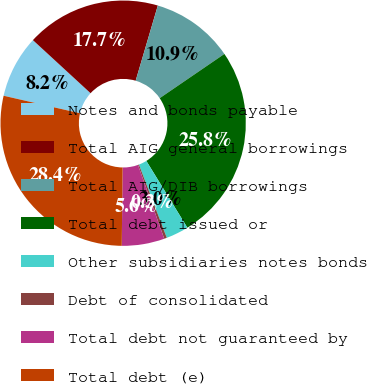Convert chart. <chart><loc_0><loc_0><loc_500><loc_500><pie_chart><fcel>Notes and bonds payable<fcel>Total AIG general borrowings<fcel>Total AIG/DIB borrowings<fcel>Total debt issued or<fcel>Other subsidiaries notes bonds<fcel>Debt of consolidated<fcel>Total debt not guaranteed by<fcel>Total debt (e)<nl><fcel>8.25%<fcel>17.72%<fcel>10.89%<fcel>25.78%<fcel>2.98%<fcel>0.35%<fcel>5.62%<fcel>28.41%<nl></chart> 